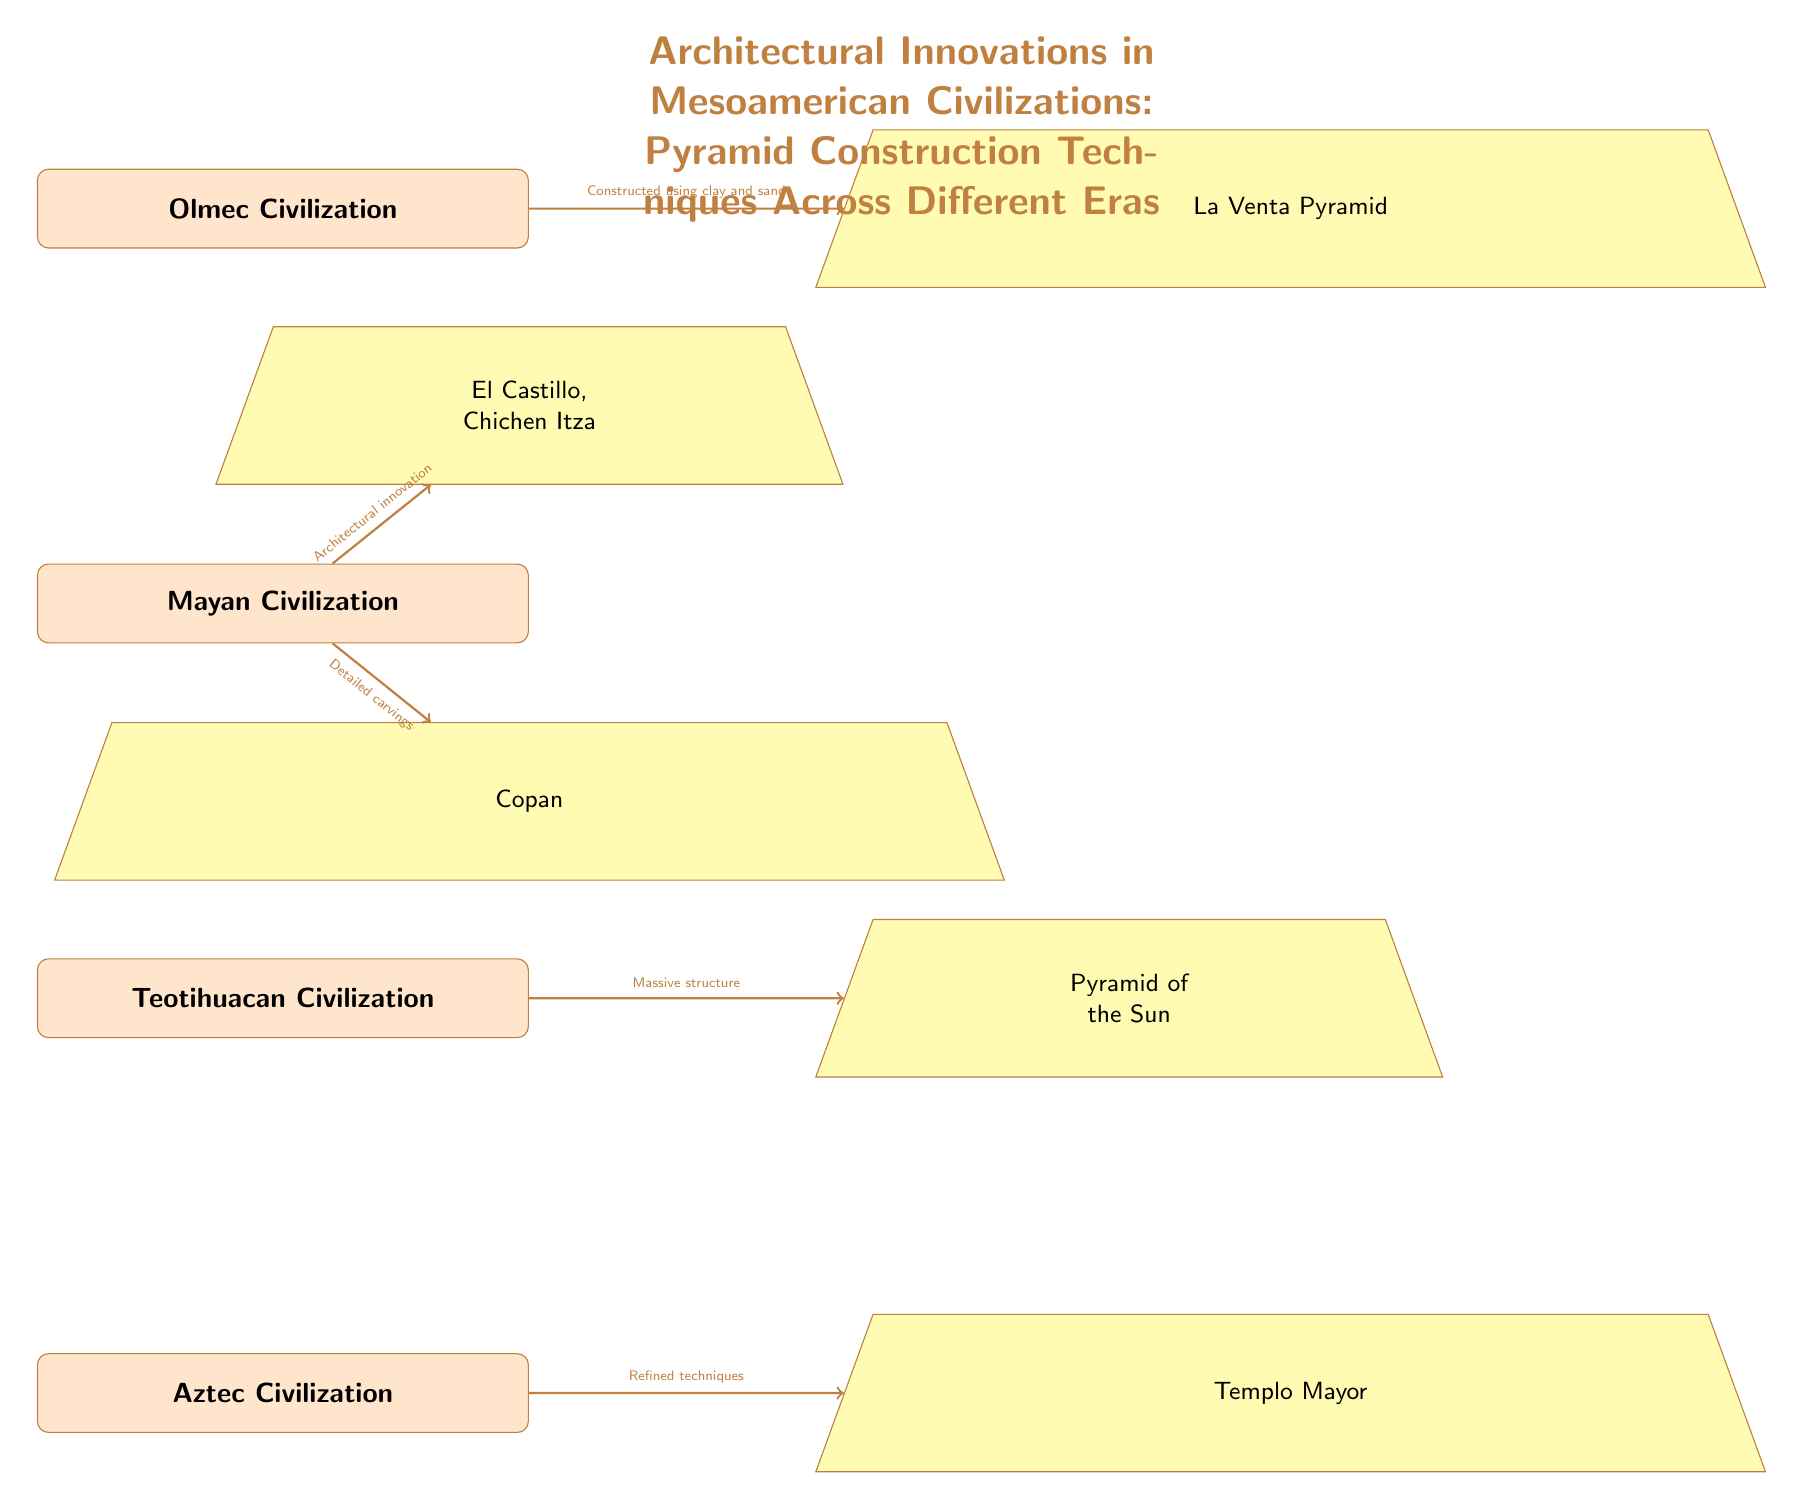What civilization is represented at the top of the diagram? The diagram presents a hierarchical arrangement where the Olmec Civilization is placed at the top. This is determined by observing the vertical node arrangement.
Answer: Olmec Civilization How many civilizations are depicted in the diagram? Counting the distinct nodes representing civilizations, there are four listed: Olmec, Mayan, Teotihuacan, and Aztec.
Answer: Four What type of material is used for the construction of La Venta Pyramid? The arrow leading from the Olmec Civilization to La Venta Pyramid specifies that it was constructed using clay and sand, as indicated by the text along the arrow.
Answer: Clay and sand Which pyramid is associated with the Mayan Civilization and noted for its architectural innovation? The diagram points to El Castillo, Chichen Itza as the pyramid of the Mayan Civilization, and it is specifically noted for its architectural innovation on the connecting arrow.
Answer: El Castillo, Chichen Itza What characteristic is highlighted for the Copan pyramid? The arrow from the Mayan Civilization to Copan emphasizes "Detailed carvings," indicating this feature is a key aspect associated with Copan.
Answer: Detailed carvings Which civilization is associated with the Pyramid of the Sun? The diagram shows that the Pyramid of the Sun is directly linked to the Teotihuacan Civilization, as shown by the arrow with the label describing its structure.
Answer: Teotihuacan Civilization What does the arrow from the Aztec Civilization to Templo Mayor indicate about construction techniques? The arrow specifies that the Templo Mayor utilized "Refined techniques," highlighting the advancements in construction methods attributed to the Aztec.
Answer: Refined techniques Which pyramid is located directly beneath the Mayan Civilization in the diagram? The diagram illustrates that Copan is placed directly below the Mayan Civilization, as indicated by the positioning of the nodes.
Answer: Copan What is the significance of the node connections between civilizations and pyramids in this diagram? The connections between the civilizations and their respective pyramids denote the relationship in terms of architectural innovations, the materials used, and specific features highlighted by labels along arrows, synthesizing the historical advancements of pyramid construction over time.
Answer: Architectural innovations 